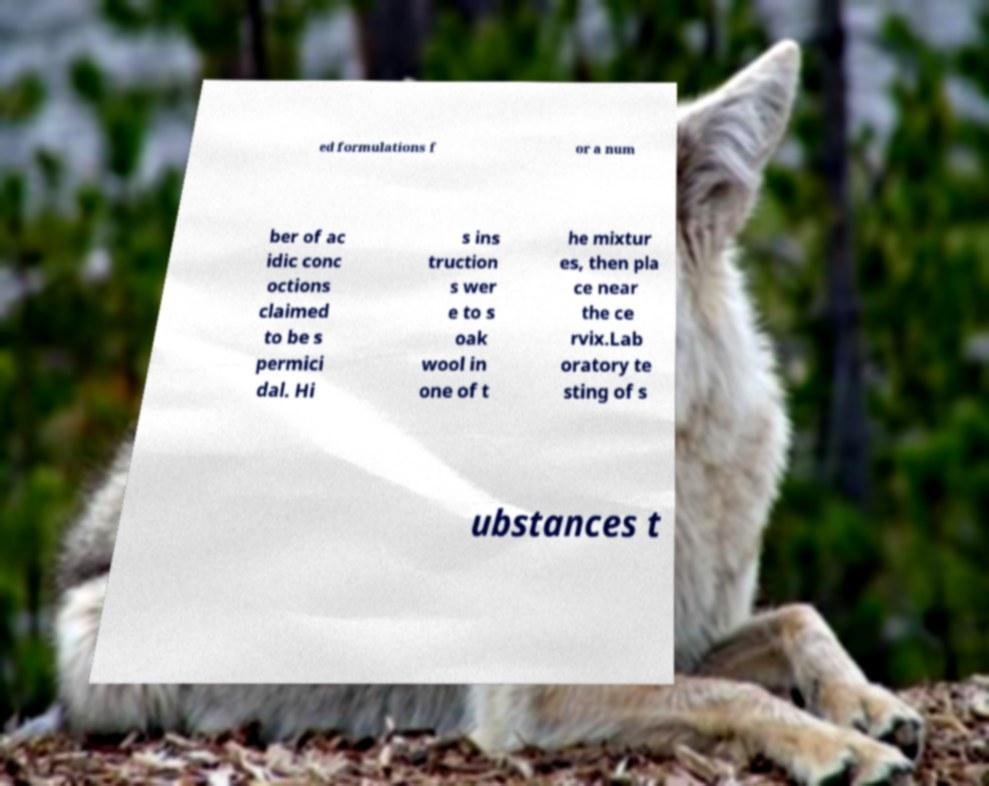Please read and relay the text visible in this image. What does it say? ed formulations f or a num ber of ac idic conc octions claimed to be s permici dal. Hi s ins truction s wer e to s oak wool in one of t he mixtur es, then pla ce near the ce rvix.Lab oratory te sting of s ubstances t 